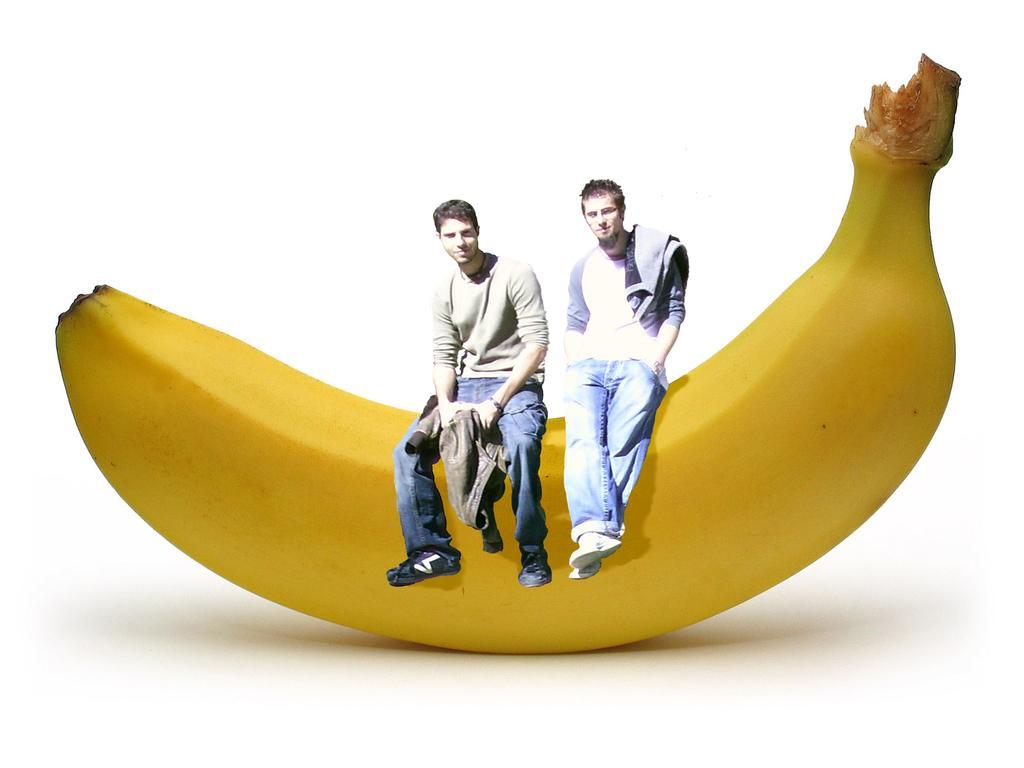Could you give a brief overview of what you see in this image? In this image I can see two people sitting on the banana. I can see these people are wearing the different color dresses. And there is a white background. 